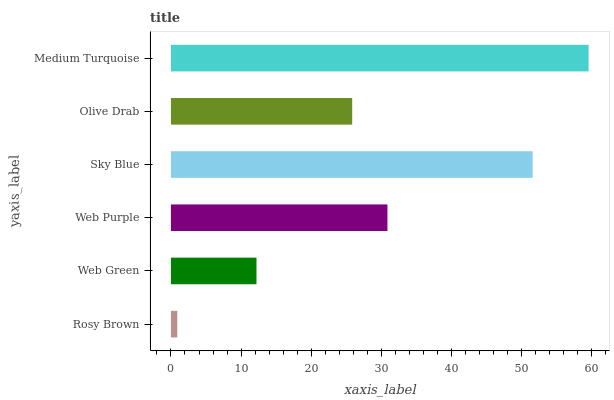Is Rosy Brown the minimum?
Answer yes or no. Yes. Is Medium Turquoise the maximum?
Answer yes or no. Yes. Is Web Green the minimum?
Answer yes or no. No. Is Web Green the maximum?
Answer yes or no. No. Is Web Green greater than Rosy Brown?
Answer yes or no. Yes. Is Rosy Brown less than Web Green?
Answer yes or no. Yes. Is Rosy Brown greater than Web Green?
Answer yes or no. No. Is Web Green less than Rosy Brown?
Answer yes or no. No. Is Web Purple the high median?
Answer yes or no. Yes. Is Olive Drab the low median?
Answer yes or no. Yes. Is Medium Turquoise the high median?
Answer yes or no. No. Is Web Green the low median?
Answer yes or no. No. 